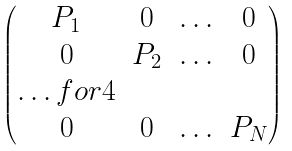<formula> <loc_0><loc_0><loc_500><loc_500>\begin{pmatrix} P _ { 1 } & 0 & \hdots & 0 \\ 0 & P _ { 2 } & \hdots & 0 \\ \hdots f o r { 4 } \\ 0 & 0 & \hdots & P _ { N } \end{pmatrix}</formula> 